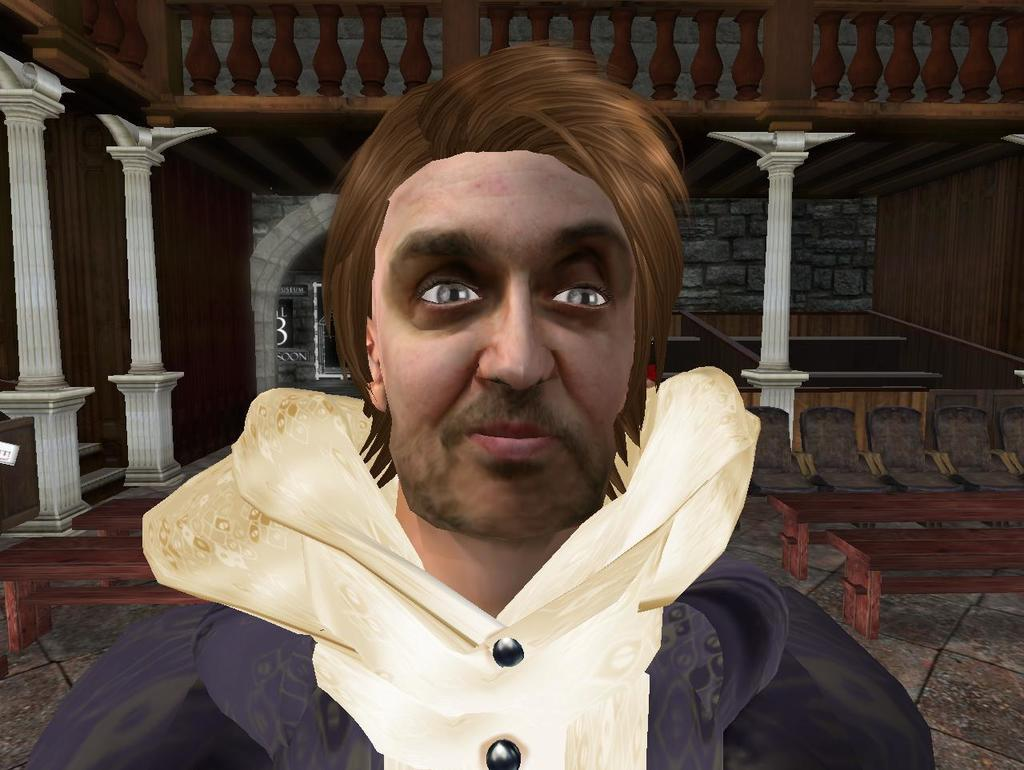What is the main subject of the image? There is a man standing in the image. What is the man wearing? The man is wearing a coat. What type of furniture can be seen in the backdrop of the image? There are chairs and tables in the backdrop of the image. What type of car is the man driving in the image? There is no car present in the image; it only features a man standing and furniture in the backdrop. 